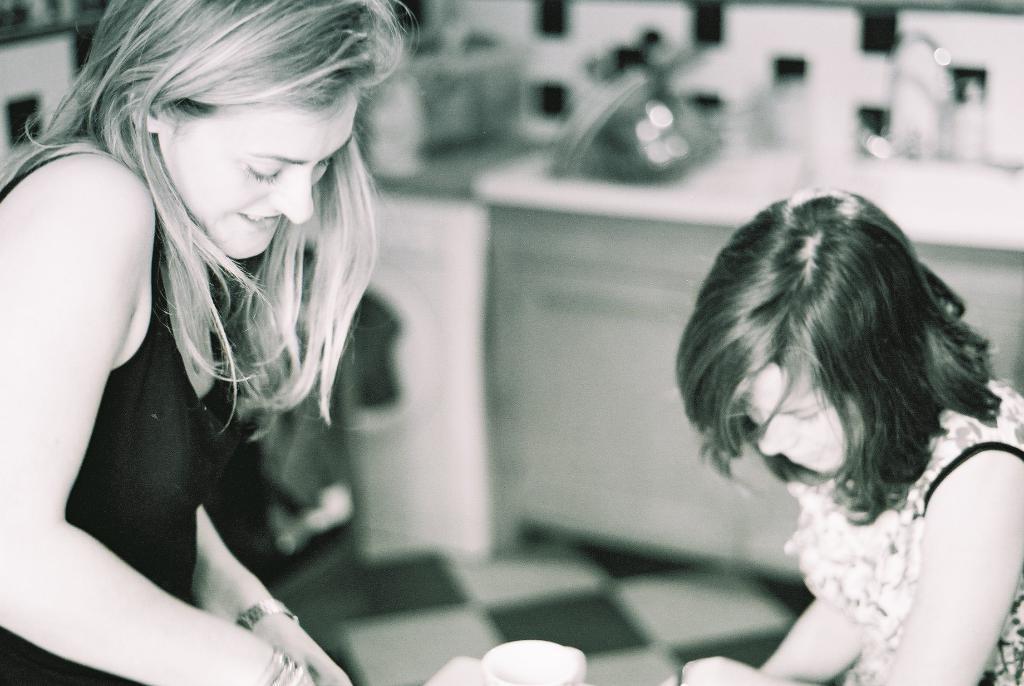How would you summarize this image in a sentence or two? It is the black and white image in which there is a girl on the left side and a kid on the right side. In between them there is a cup. 